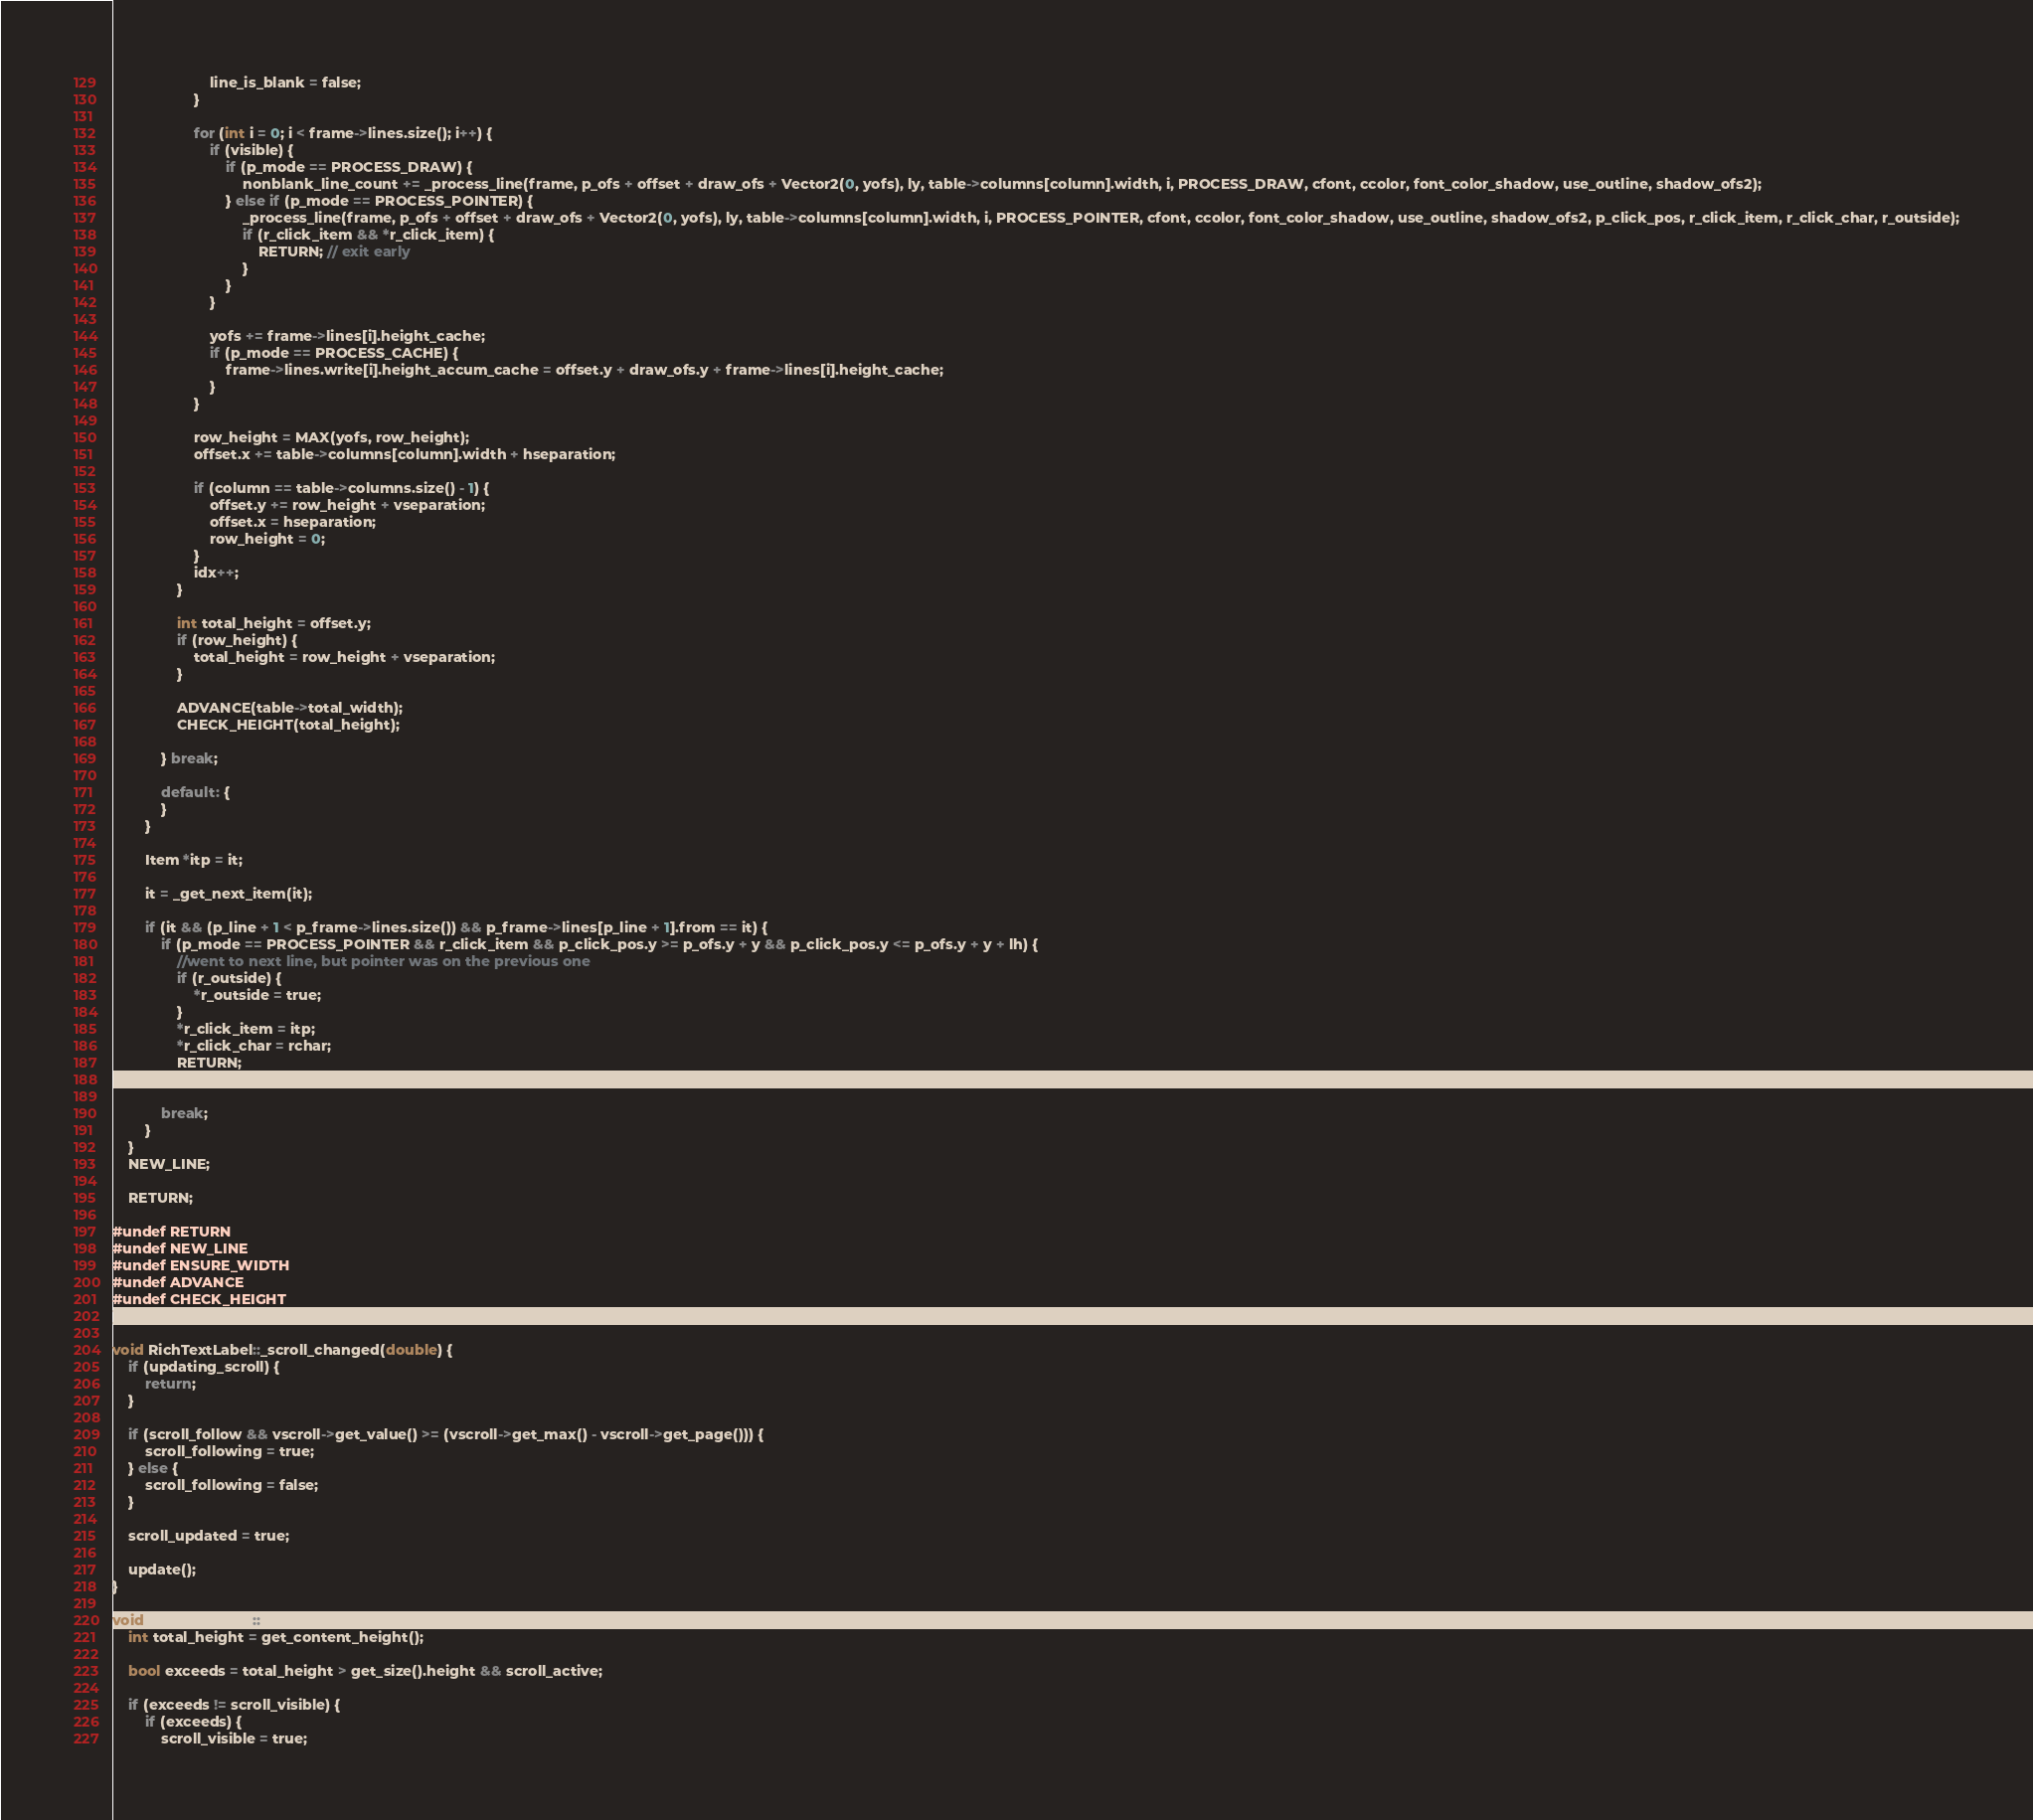Convert code to text. <code><loc_0><loc_0><loc_500><loc_500><_C++_>						line_is_blank = false;
					}

					for (int i = 0; i < frame->lines.size(); i++) {
						if (visible) {
							if (p_mode == PROCESS_DRAW) {
								nonblank_line_count += _process_line(frame, p_ofs + offset + draw_ofs + Vector2(0, yofs), ly, table->columns[column].width, i, PROCESS_DRAW, cfont, ccolor, font_color_shadow, use_outline, shadow_ofs2);
							} else if (p_mode == PROCESS_POINTER) {
								_process_line(frame, p_ofs + offset + draw_ofs + Vector2(0, yofs), ly, table->columns[column].width, i, PROCESS_POINTER, cfont, ccolor, font_color_shadow, use_outline, shadow_ofs2, p_click_pos, r_click_item, r_click_char, r_outside);
								if (r_click_item && *r_click_item) {
									RETURN; // exit early
								}
							}
						}

						yofs += frame->lines[i].height_cache;
						if (p_mode == PROCESS_CACHE) {
							frame->lines.write[i].height_accum_cache = offset.y + draw_ofs.y + frame->lines[i].height_cache;
						}
					}

					row_height = MAX(yofs, row_height);
					offset.x += table->columns[column].width + hseparation;

					if (column == table->columns.size() - 1) {
						offset.y += row_height + vseparation;
						offset.x = hseparation;
						row_height = 0;
					}
					idx++;
				}

				int total_height = offset.y;
				if (row_height) {
					total_height = row_height + vseparation;
				}

				ADVANCE(table->total_width);
				CHECK_HEIGHT(total_height);

			} break;

			default: {
			}
		}

		Item *itp = it;

		it = _get_next_item(it);

		if (it && (p_line + 1 < p_frame->lines.size()) && p_frame->lines[p_line + 1].from == it) {
			if (p_mode == PROCESS_POINTER && r_click_item && p_click_pos.y >= p_ofs.y + y && p_click_pos.y <= p_ofs.y + y + lh) {
				//went to next line, but pointer was on the previous one
				if (r_outside) {
					*r_outside = true;
				}
				*r_click_item = itp;
				*r_click_char = rchar;
				RETURN;
			}

			break;
		}
	}
	NEW_LINE;

	RETURN;

#undef RETURN
#undef NEW_LINE
#undef ENSURE_WIDTH
#undef ADVANCE
#undef CHECK_HEIGHT
}

void RichTextLabel::_scroll_changed(double) {
	if (updating_scroll) {
		return;
	}

	if (scroll_follow && vscroll->get_value() >= (vscroll->get_max() - vscroll->get_page())) {
		scroll_following = true;
	} else {
		scroll_following = false;
	}

	scroll_updated = true;

	update();
}

void RichTextLabel::_update_scroll() {
	int total_height = get_content_height();

	bool exceeds = total_height > get_size().height && scroll_active;

	if (exceeds != scroll_visible) {
		if (exceeds) {
			scroll_visible = true;</code> 